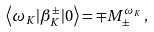Convert formula to latex. <formula><loc_0><loc_0><loc_500><loc_500>\left \langle \omega _ { K } | \beta _ { K } ^ { \pm } | 0 \right \rangle = \mp M ^ { \omega _ { K } } _ { \pm } \, ,</formula> 